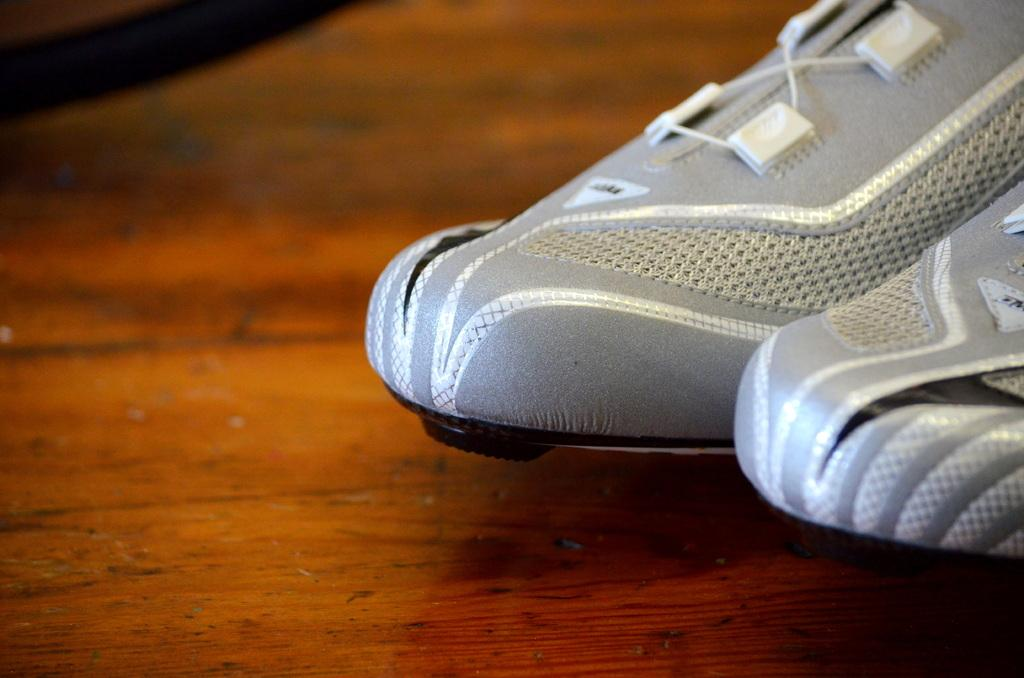What type of footwear is visible in the image? There are sneakers in the image. Where are the sneakers located? The sneakers are placed on a surface. What type of pest can be seen crawling on the sneakers in the image? There is no pest visible on the sneakers in the image. Can you describe the person wearing the sneakers in the image? There is no person visible in the image, only the sneakers. 